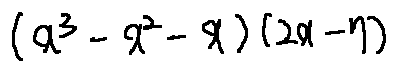<formula> <loc_0><loc_0><loc_500><loc_500>( x ^ { 3 } - x ^ { 2 } - x ) ( 2 x - 7 )</formula> 